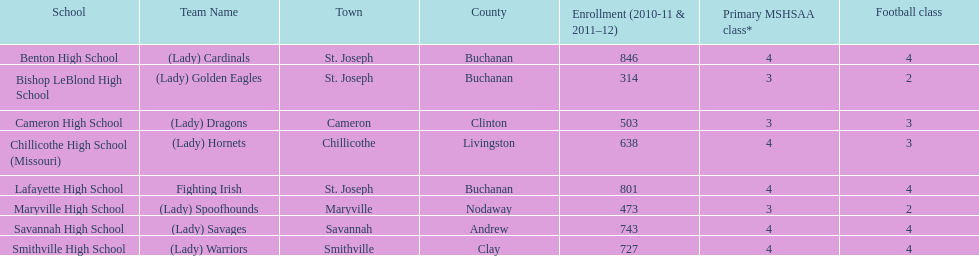Help me parse the entirety of this table. {'header': ['School', 'Team Name', 'Town', 'County', 'Enrollment (2010-11 & 2011–12)', 'Primary MSHSAA class*', 'Football class'], 'rows': [['Benton High School', '(Lady) Cardinals', 'St. Joseph', 'Buchanan', '846', '4', '4'], ['Bishop LeBlond High School', '(Lady) Golden Eagles', 'St. Joseph', 'Buchanan', '314', '3', '2'], ['Cameron High School', '(Lady) Dragons', 'Cameron', 'Clinton', '503', '3', '3'], ['Chillicothe High School (Missouri)', '(Lady) Hornets', 'Chillicothe', 'Livingston', '638', '4', '3'], ['Lafayette High School', 'Fighting Irish', 'St. Joseph', 'Buchanan', '801', '4', '4'], ['Maryville High School', '(Lady) Spoofhounds', 'Maryville', 'Nodaway', '473', '3', '2'], ['Savannah High School', '(Lady) Savages', 'Savannah', 'Andrew', '743', '4', '4'], ['Smithville High School', '(Lady) Warriors', 'Smithville', 'Clay', '727', '4', '4']]} In the academic years 2010-2011 and 2011-2012, at which school was the student enrollment the lowest? Bishop LeBlond High School. 